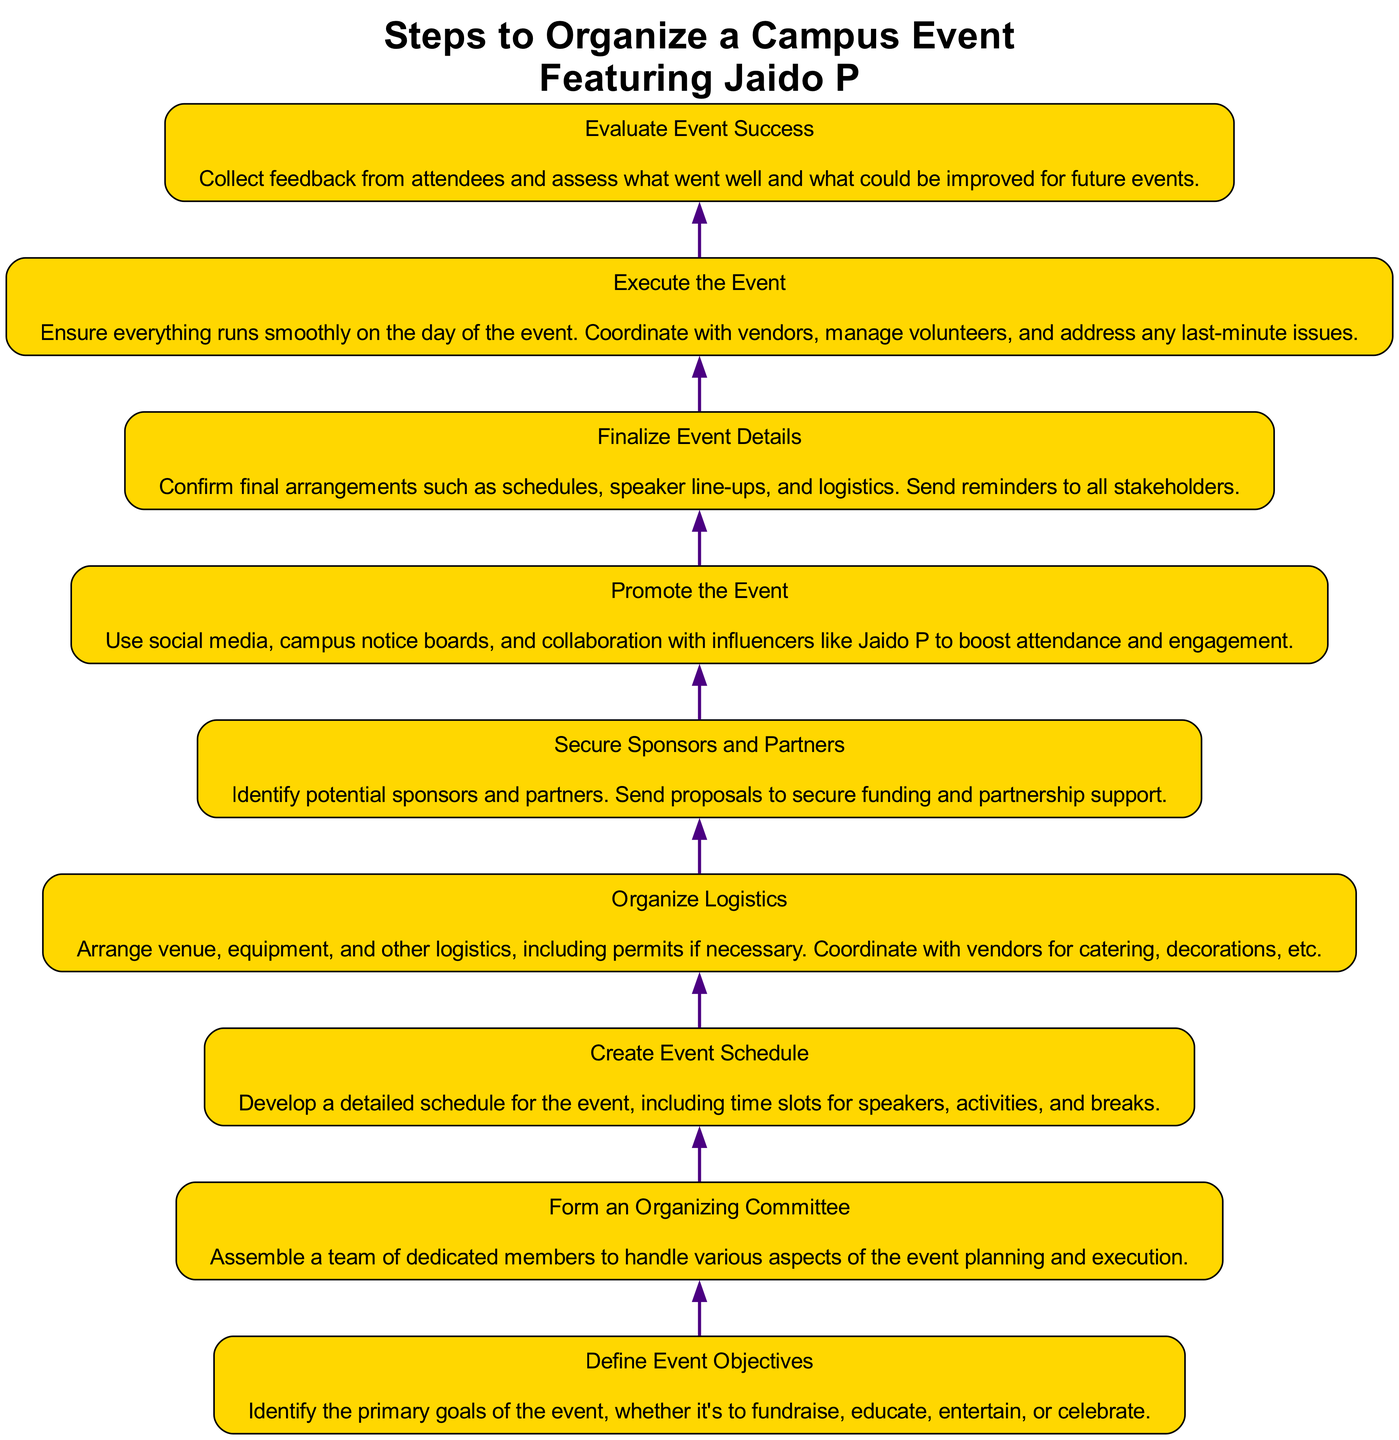What is the first step in the event organization process? The first step in organizing the event is "Define Event Objectives," which is at the bottom of the flow chart. This step identifies the primary goals of the event.
Answer: Define Event Objectives How many steps are there in total? The flow chart contains a total of nine steps, which can be counted directly from the nodes depicted in the diagram.
Answer: Nine Which step precedes "Promote the Event"? The step that comes right before "Promote the Event" is "Finalize Event Details," as indicated by the direct connection (edge) that shows the flow between these two steps.
Answer: Finalize Event Details What is the last step in the event planning diagram? The last step, located at the top of the diagram, is "Evaluate Event Success," which assesses the event after it has been executed.
Answer: Evaluate Event Success Which steps involve logistics? The steps that involve logistics are "Organize Logistics" and "Finalize Event Details," as they both mention managing arrangements and details necessary for the event's smooth operation.
Answer: Organize Logistics, Finalize Event Details What is the purpose of "Secure Sponsors and Partners"? The purpose of this step is to identify potential sponsors and partners to secure funding and partnership support needed for the event, as described in the flow.
Answer: Secure funding and partnership support How does "Create Event Schedule" relate to "Execute the Event"? "Create Event Schedule" is necessary to provide a structured timeline of activities, which is then implemented during the "Execute the Event" step to ensure everything runs as planned.
Answer: Provides structured timeline In what order do the first three steps appear in the chart? The first three steps according to the flow chart from bottom to top are "Define Event Objectives," "Form an Organizing Committee," and "Create Event Schedule," reflecting the foundational work required before execution.
Answer: Define Event Objectives, Form an Organizing Committee, Create Event Schedule Which step directly supports the promotion of the event? The step that directly supports the promotion of the event is "Secure Sponsors and Partners," as having sponsors can enhance promotional efforts and attract attendees.
Answer: Secure Sponsors and Partners 